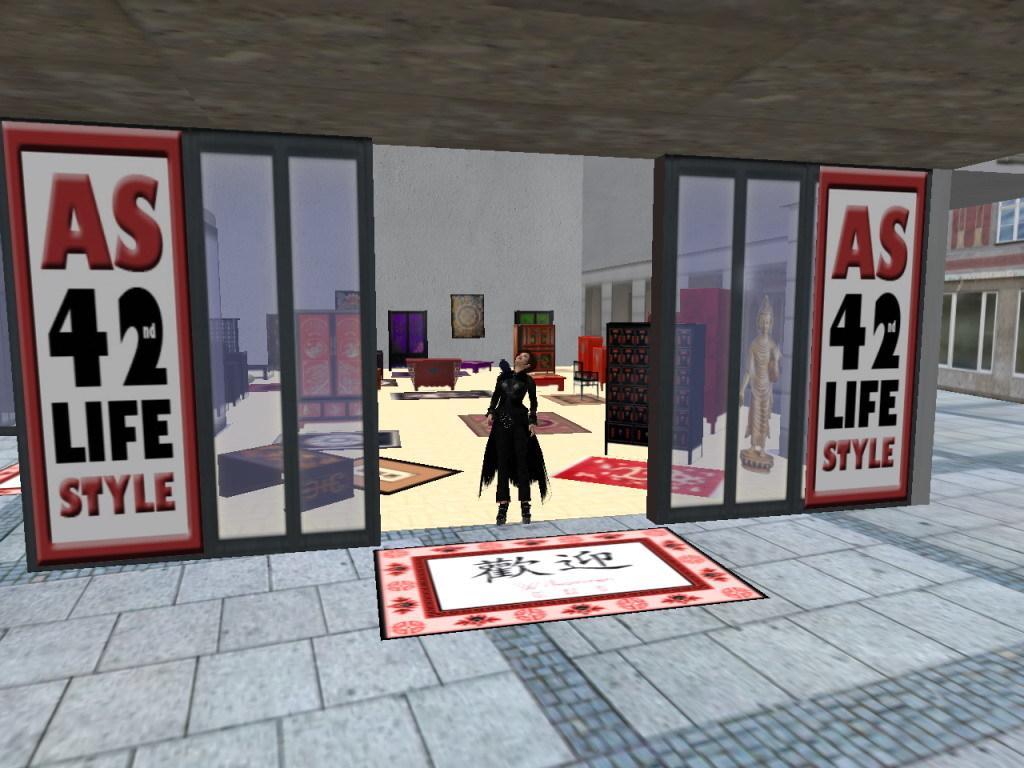Please provide a concise description of this image. This is an animation and here we can see a person wearing a jacket and in the background, there are boards and we can see frames, chairs, racks and there are some stands. At the bottom, there are mats on the floor and there is a road. 